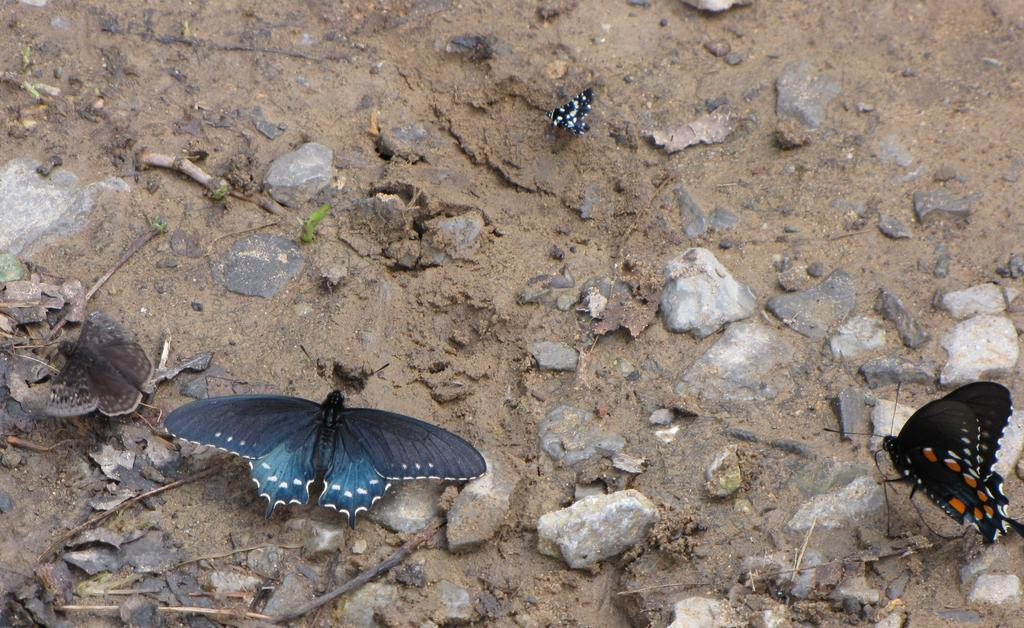What type of animals can be seen in the image? There are butterflies in the image. What colors are the butterflies? The butterflies are in different colors. What is at the bottom of the image? There is mud at the bottom of the image. What other natural elements can be seen in the image? There are stones, dried leaves, and sticks visible in the image. How do the butterflies help the bikes in the image? There are no bikes present in the image, so the butterflies cannot help them. 